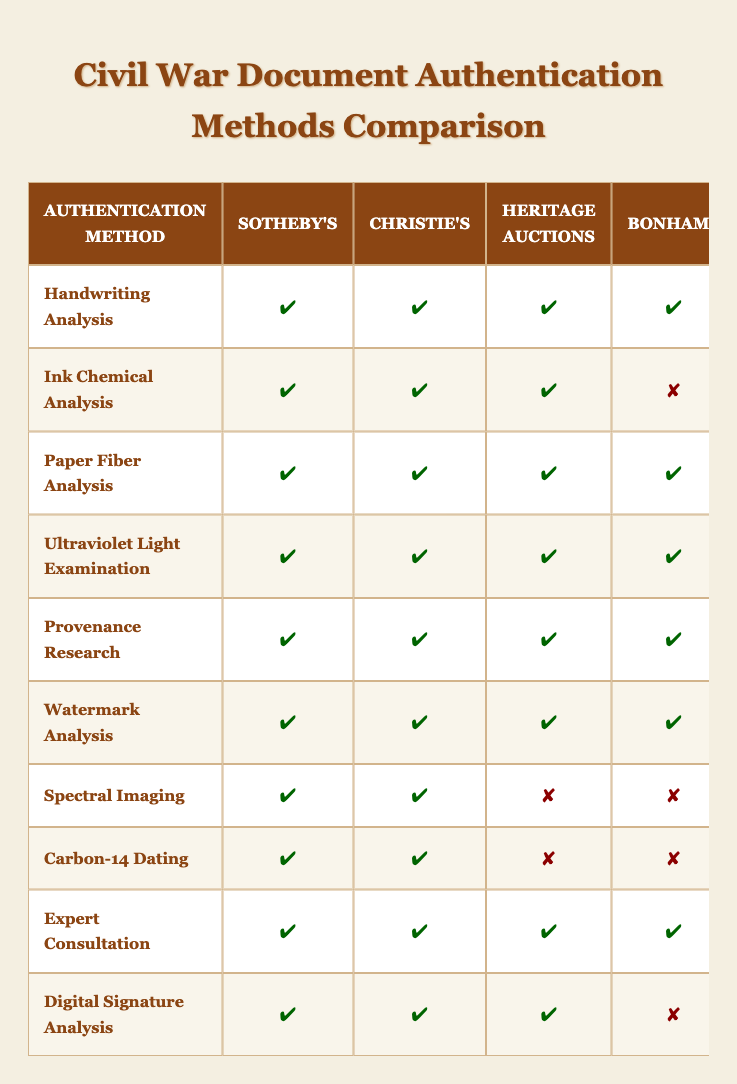What authentication methods are used by all auction houses? By examining each authentication method, I can see that "Handwriting Analysis," "Paper Fiber Analysis," "Provenance Research," and "Watermark Analysis" are marked as true for all highlighted auction houses.
Answer: Handwriting Analysis, Paper Fiber Analysis, Provenance Research, Watermark Analysis Which authentication method is exclusively available to Sotheby's and Christie's? Looking at the methods, both Sotheby's and Christie's have unique access to "Spectral Imaging" and "Carbon-14 Dating," while Heritage Auctions, Bonhams, and Cowan's Auctions do not offer these methods.
Answer: Spectral Imaging, Carbon-14 Dating How many auction houses use Ink Chemical Analysis? Counting the number of auction houses marked true for "Ink Chemical Analysis," we have Sotheby's, Christie's, and Heritage Auctions, which amounts to 3 houses.
Answer: 3 Is there any method that Cowan's Auctions does not provide? A quick check of Cowan's Auctions shows that it does not provide access to "Ink Chemical Analysis," "Ultraviolet Light Examination," "Spectral Imaging," "Carbon-14 Dating," and "Digital Signature Analysis." Hence, there are multiple methods not provided.
Answer: Yes Which authentication method has the most auction house support? By scanning the methods, "Handwriting Analysis," "Paper Fiber Analysis," "Provenance Research," and "Watermark Analysis" have support from all five auction houses, indicating they are the most accepted methods.
Answer: Handwriting Analysis, Paper Fiber Analysis, Provenance Research, Watermark Analysis How does the use of Digital Signature Analysis compare between Sotheby's and Bonhams? Looking at the table, Sotheby's uses Digital Signature Analysis while Bonhams does not; this indicates a discrepancy in the authentication method offered between the two auction houses.
Answer: Sotheby's uses it; Bonhams does not What is the total number of authentication methods employed by Heritage Auctions? Heritage Auctions has methods listed as true for "Handwriting Analysis," "Ink Chemical Analysis," "Paper Fiber Analysis," "Ultraviolet Light Examination," "Provenance Research," and "Expert Consultation," making it a total of 6 methods.
Answer: 6 Do any auction houses use both Carbon-14 Dating and Spectral Imaging? A review of the table shows that Sotheby’s and Christie’s utilize Carbon-14 Dating, but Heritage Auctions, Bonhams, and Cowan's Auctions do not use it at all, meaning no auction house employs both methods.
Answer: No Which auction house provides the least number of authentication methods? Counting the number of methods per auction house, Bonhams and Cowan's Auctions have the least, with only 5 methods listed as true, making them the auction houses with the least number of methods.
Answer: Bonhams, Cowan's Auctions 